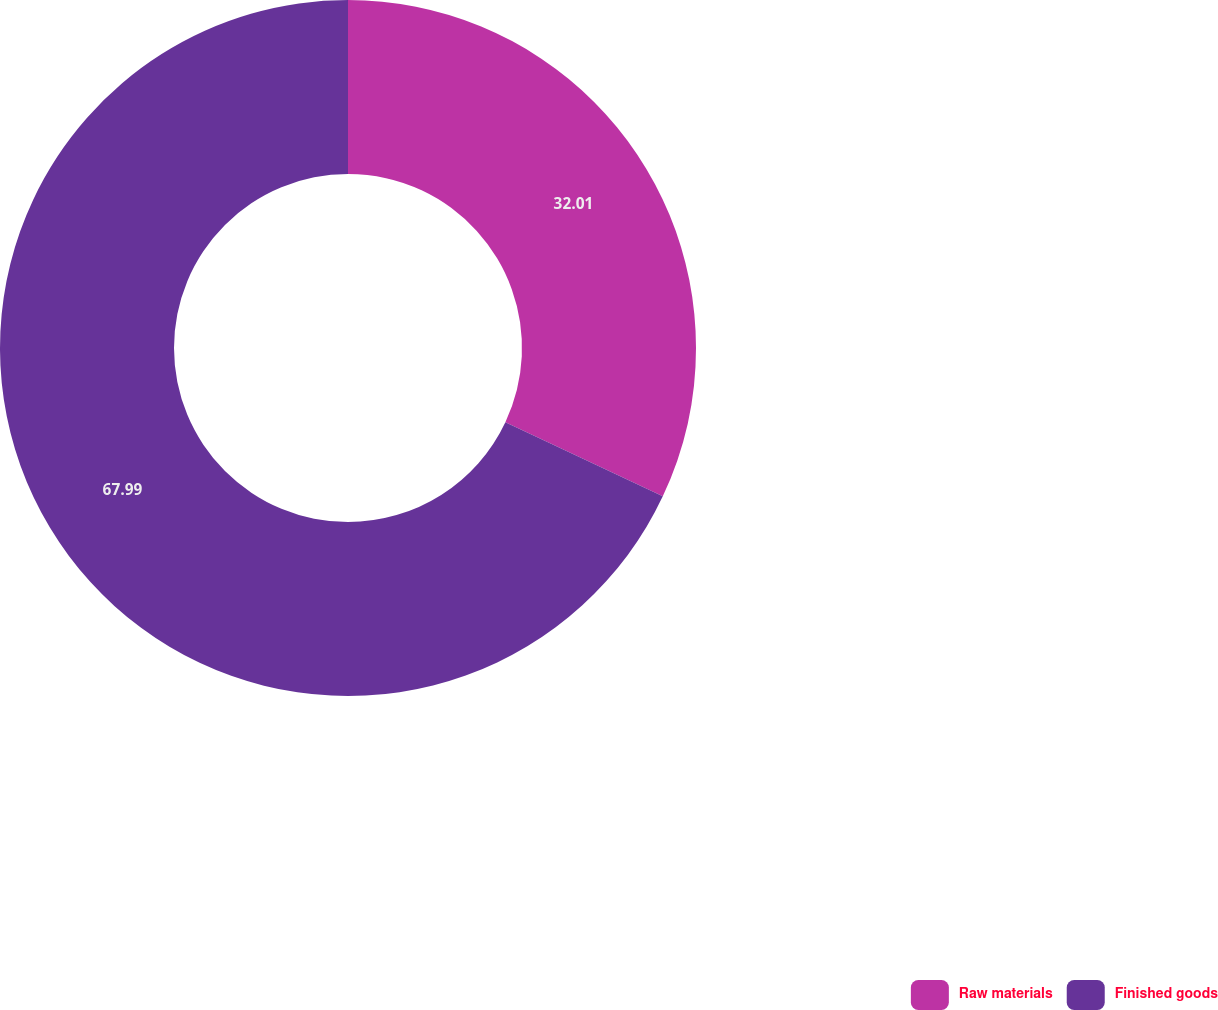<chart> <loc_0><loc_0><loc_500><loc_500><pie_chart><fcel>Raw materials<fcel>Finished goods<nl><fcel>32.01%<fcel>67.99%<nl></chart> 